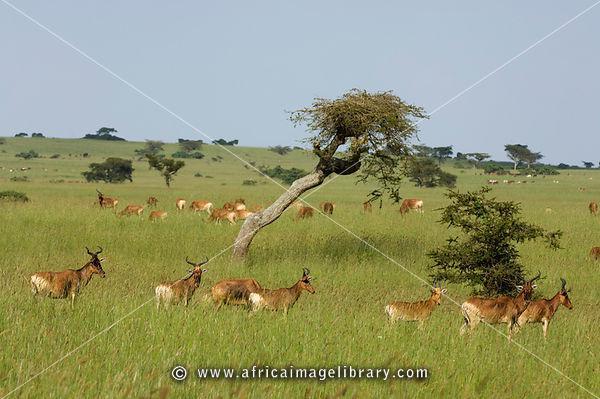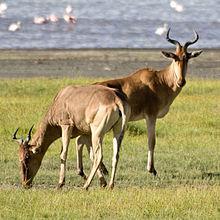The first image is the image on the left, the second image is the image on the right. Evaluate the accuracy of this statement regarding the images: "One of the images features an animal facing left with it's head turned straight.". Is it true? Answer yes or no. No. 